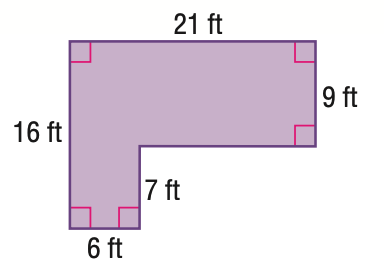Answer the mathemtical geometry problem and directly provide the correct option letter.
Question: Find the area of the figure. Round to the nearest tenth.
Choices: A: 189 B: 231 C: 294 D: 336 B 